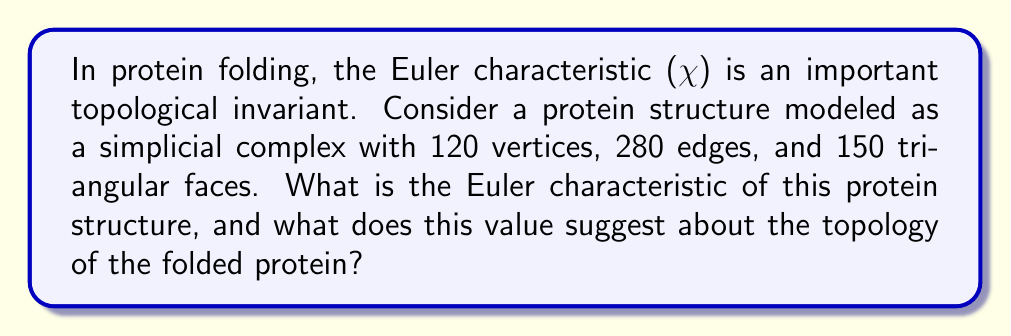Can you answer this question? To solve this problem, we'll follow these steps:

1. Recall the formula for the Euler characteristic:
   For a simplicial complex, the Euler characteristic is given by:
   $$\chi = V - E + F$$
   where V is the number of vertices, E is the number of edges, and F is the number of faces.

2. Insert the given values into the formula:
   V = 120 (vertices)
   E = 280 (edges)
   F = 150 (triangular faces)

3. Calculate the Euler characteristic:
   $$\chi = 120 - 280 + 150 = -10$$

4. Interpret the result:
   The Euler characteristic is a topological invariant, meaning it doesn't change under continuous deformations of the surface. For closed surfaces:
   - A sphere has $\chi = 2$
   - A torus has $\chi = 0$
   - A surface with g holes (genus g) has $\chi = 2 - 2g$

   Our result of $\chi = -10$ suggests a surface with multiple holes. We can solve for g:
   $$-10 = 2 - 2g$$
   $$-12 = -2g$$
   $$g = 6$$

5. Biological interpretation:
   A genus of 6 in the protein structure suggests a complex folded shape with multiple "holes" or tunnels. This could indicate:
   - Potential binding sites for other molecules
   - Channels for ion transport
   - A highly compact and intricate tertiary structure

Such topological features are often crucial for the protein's function, especially in enzymes or membrane proteins.
Answer: The Euler characteristic of the protein structure is $\chi = -10$, suggesting a topological equivalent to a surface with 6 holes (genus 6). This indicates a complex folded structure with multiple tunnels or cavities, which may be important for the protein's biological function. 